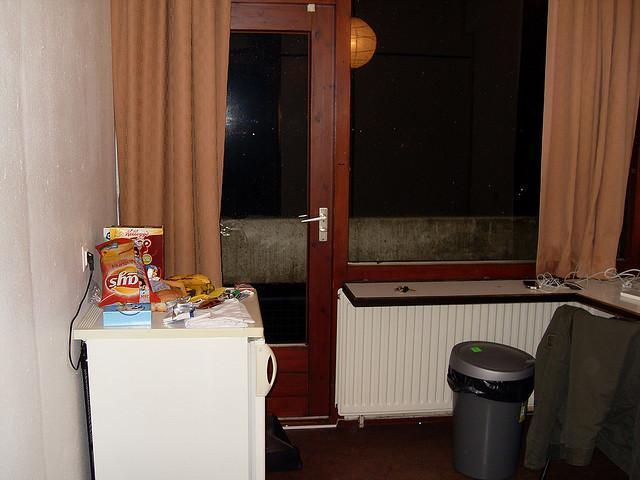How many clock faces are there?
Give a very brief answer. 0. 